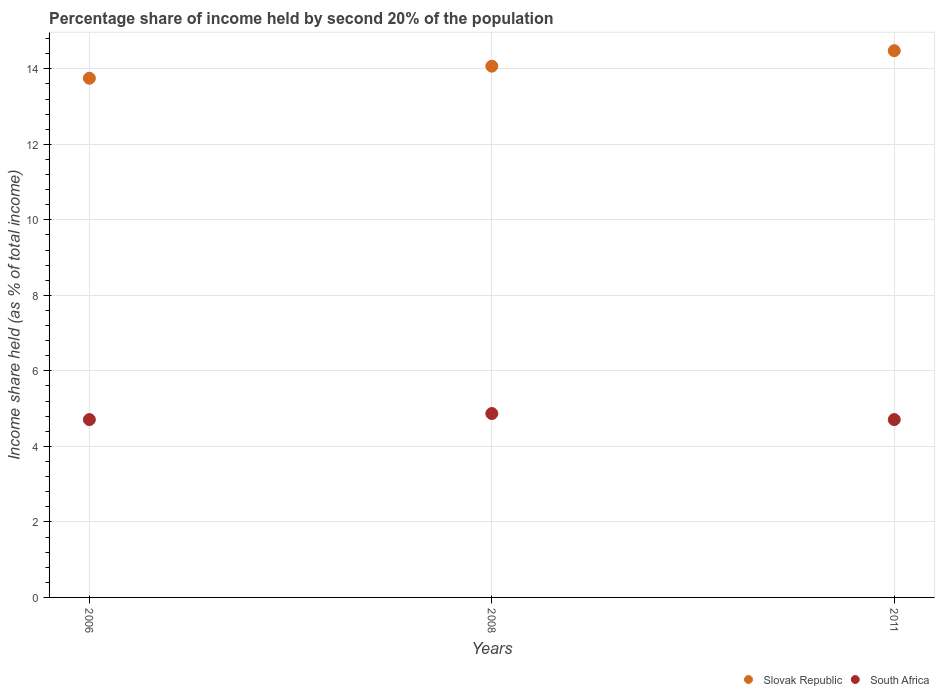How many different coloured dotlines are there?
Your response must be concise. 2. What is the share of income held by second 20% of the population in Slovak Republic in 2008?
Your answer should be compact. 14.07. Across all years, what is the maximum share of income held by second 20% of the population in South Africa?
Offer a very short reply. 4.87. Across all years, what is the minimum share of income held by second 20% of the population in Slovak Republic?
Offer a very short reply. 13.75. In which year was the share of income held by second 20% of the population in South Africa minimum?
Offer a terse response. 2006. What is the total share of income held by second 20% of the population in South Africa in the graph?
Offer a very short reply. 14.29. What is the difference between the share of income held by second 20% of the population in Slovak Republic in 2006 and that in 2008?
Offer a very short reply. -0.32. What is the difference between the share of income held by second 20% of the population in Slovak Republic in 2006 and the share of income held by second 20% of the population in South Africa in 2011?
Your answer should be very brief. 9.04. What is the average share of income held by second 20% of the population in South Africa per year?
Your answer should be very brief. 4.76. In the year 2011, what is the difference between the share of income held by second 20% of the population in South Africa and share of income held by second 20% of the population in Slovak Republic?
Offer a very short reply. -9.77. In how many years, is the share of income held by second 20% of the population in Slovak Republic greater than 13.2 %?
Offer a terse response. 3. What is the ratio of the share of income held by second 20% of the population in Slovak Republic in 2008 to that in 2011?
Offer a terse response. 0.97. Is the share of income held by second 20% of the population in South Africa in 2008 less than that in 2011?
Keep it short and to the point. No. Is the difference between the share of income held by second 20% of the population in South Africa in 2006 and 2011 greater than the difference between the share of income held by second 20% of the population in Slovak Republic in 2006 and 2011?
Keep it short and to the point. Yes. What is the difference between the highest and the second highest share of income held by second 20% of the population in Slovak Republic?
Ensure brevity in your answer.  0.41. What is the difference between the highest and the lowest share of income held by second 20% of the population in South Africa?
Provide a succinct answer. 0.16. In how many years, is the share of income held by second 20% of the population in Slovak Republic greater than the average share of income held by second 20% of the population in Slovak Republic taken over all years?
Your answer should be very brief. 1. Does the share of income held by second 20% of the population in South Africa monotonically increase over the years?
Give a very brief answer. No. Is the share of income held by second 20% of the population in South Africa strictly greater than the share of income held by second 20% of the population in Slovak Republic over the years?
Offer a terse response. No. How many dotlines are there?
Ensure brevity in your answer.  2. How many years are there in the graph?
Offer a very short reply. 3. What is the difference between two consecutive major ticks on the Y-axis?
Offer a terse response. 2. Are the values on the major ticks of Y-axis written in scientific E-notation?
Provide a short and direct response. No. Where does the legend appear in the graph?
Offer a very short reply. Bottom right. How many legend labels are there?
Keep it short and to the point. 2. What is the title of the graph?
Provide a short and direct response. Percentage share of income held by second 20% of the population. Does "Micronesia" appear as one of the legend labels in the graph?
Give a very brief answer. No. What is the label or title of the Y-axis?
Give a very brief answer. Income share held (as % of total income). What is the Income share held (as % of total income) of Slovak Republic in 2006?
Give a very brief answer. 13.75. What is the Income share held (as % of total income) in South Africa in 2006?
Offer a very short reply. 4.71. What is the Income share held (as % of total income) of Slovak Republic in 2008?
Provide a short and direct response. 14.07. What is the Income share held (as % of total income) in South Africa in 2008?
Your answer should be compact. 4.87. What is the Income share held (as % of total income) in Slovak Republic in 2011?
Provide a short and direct response. 14.48. What is the Income share held (as % of total income) in South Africa in 2011?
Your response must be concise. 4.71. Across all years, what is the maximum Income share held (as % of total income) of Slovak Republic?
Your response must be concise. 14.48. Across all years, what is the maximum Income share held (as % of total income) of South Africa?
Offer a very short reply. 4.87. Across all years, what is the minimum Income share held (as % of total income) of Slovak Republic?
Give a very brief answer. 13.75. Across all years, what is the minimum Income share held (as % of total income) in South Africa?
Offer a very short reply. 4.71. What is the total Income share held (as % of total income) in Slovak Republic in the graph?
Provide a short and direct response. 42.3. What is the total Income share held (as % of total income) of South Africa in the graph?
Your answer should be compact. 14.29. What is the difference between the Income share held (as % of total income) in Slovak Republic in 2006 and that in 2008?
Your response must be concise. -0.32. What is the difference between the Income share held (as % of total income) in South Africa in 2006 and that in 2008?
Provide a short and direct response. -0.16. What is the difference between the Income share held (as % of total income) of Slovak Republic in 2006 and that in 2011?
Provide a short and direct response. -0.73. What is the difference between the Income share held (as % of total income) of South Africa in 2006 and that in 2011?
Your response must be concise. 0. What is the difference between the Income share held (as % of total income) in Slovak Republic in 2008 and that in 2011?
Offer a terse response. -0.41. What is the difference between the Income share held (as % of total income) of South Africa in 2008 and that in 2011?
Your response must be concise. 0.16. What is the difference between the Income share held (as % of total income) in Slovak Republic in 2006 and the Income share held (as % of total income) in South Africa in 2008?
Your response must be concise. 8.88. What is the difference between the Income share held (as % of total income) of Slovak Republic in 2006 and the Income share held (as % of total income) of South Africa in 2011?
Offer a very short reply. 9.04. What is the difference between the Income share held (as % of total income) in Slovak Republic in 2008 and the Income share held (as % of total income) in South Africa in 2011?
Your response must be concise. 9.36. What is the average Income share held (as % of total income) of Slovak Republic per year?
Offer a terse response. 14.1. What is the average Income share held (as % of total income) in South Africa per year?
Offer a terse response. 4.76. In the year 2006, what is the difference between the Income share held (as % of total income) of Slovak Republic and Income share held (as % of total income) of South Africa?
Give a very brief answer. 9.04. In the year 2011, what is the difference between the Income share held (as % of total income) in Slovak Republic and Income share held (as % of total income) in South Africa?
Keep it short and to the point. 9.77. What is the ratio of the Income share held (as % of total income) in Slovak Republic in 2006 to that in 2008?
Your answer should be very brief. 0.98. What is the ratio of the Income share held (as % of total income) of South Africa in 2006 to that in 2008?
Your answer should be compact. 0.97. What is the ratio of the Income share held (as % of total income) in Slovak Republic in 2006 to that in 2011?
Give a very brief answer. 0.95. What is the ratio of the Income share held (as % of total income) of South Africa in 2006 to that in 2011?
Offer a very short reply. 1. What is the ratio of the Income share held (as % of total income) of Slovak Republic in 2008 to that in 2011?
Give a very brief answer. 0.97. What is the ratio of the Income share held (as % of total income) in South Africa in 2008 to that in 2011?
Your response must be concise. 1.03. What is the difference between the highest and the second highest Income share held (as % of total income) in Slovak Republic?
Keep it short and to the point. 0.41. What is the difference between the highest and the second highest Income share held (as % of total income) in South Africa?
Your response must be concise. 0.16. What is the difference between the highest and the lowest Income share held (as % of total income) in Slovak Republic?
Your answer should be very brief. 0.73. What is the difference between the highest and the lowest Income share held (as % of total income) of South Africa?
Provide a short and direct response. 0.16. 